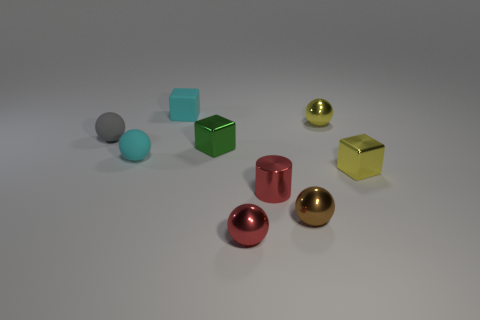There is a tiny sphere that is the same color as the metal cylinder; what is its material?
Your response must be concise. Metal. Is the number of small green metal cubes in front of the small brown object less than the number of large red metallic cylinders?
Offer a very short reply. No. Is the number of brown spheres greater than the number of big brown shiny balls?
Offer a very short reply. Yes. There is a small yellow metallic thing in front of the matte sphere behind the green thing; is there a small cyan matte block that is to the right of it?
Provide a short and direct response. No. How many other things are there of the same size as the matte cube?
Offer a very short reply. 8. There is a tiny cyan sphere; are there any objects to the left of it?
Your response must be concise. Yes. Do the cylinder and the metal ball that is to the left of the small red cylinder have the same color?
Offer a very short reply. Yes. There is a small metal ball that is behind the tiny metal cylinder to the right of the small metallic sphere that is on the left side of the red metal cylinder; what color is it?
Provide a short and direct response. Yellow. Are there any blue matte things that have the same shape as the small gray thing?
Your answer should be very brief. No. What color is the cylinder that is the same size as the green metal cube?
Offer a very short reply. Red. 